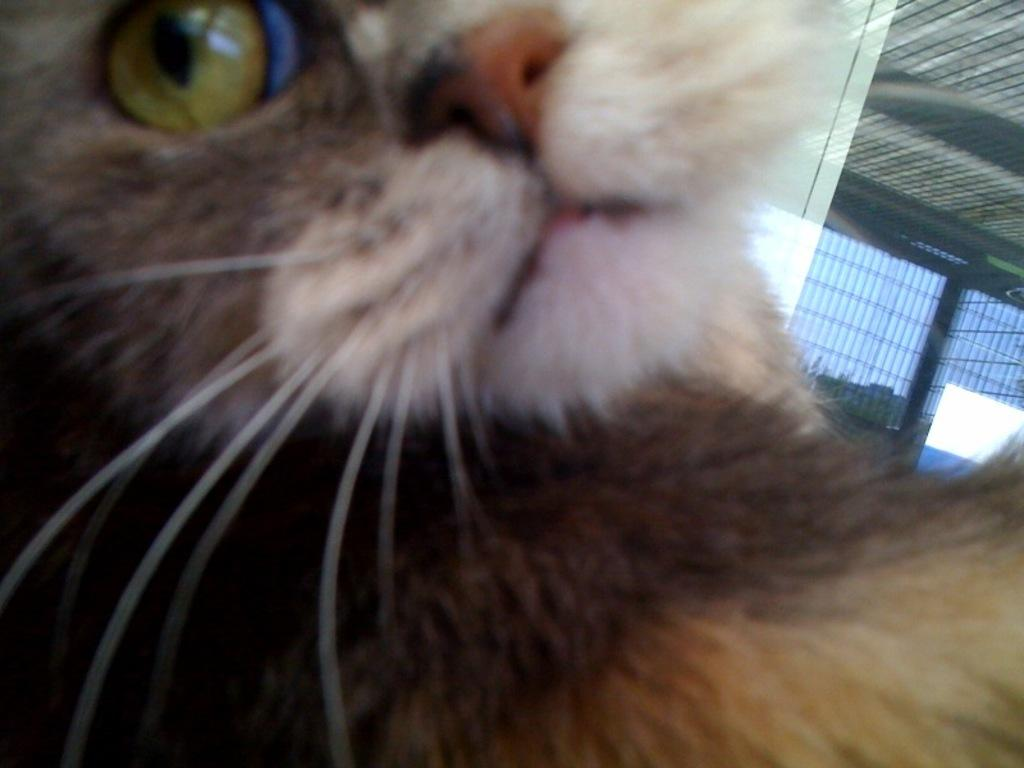What is the main subject in the center of the image? There is a cat in the center of the image. What can be seen on the right side of the image? There is a window on the right side of the image. What architectural feature is visible in the image? There is a roof visible in the image. What is visible in the background of the image? The sky is present in the image. What type of furniture is present on the desk in the image? There is no desk present in the image; it only features a cat, a window, a roof, and the sky. 